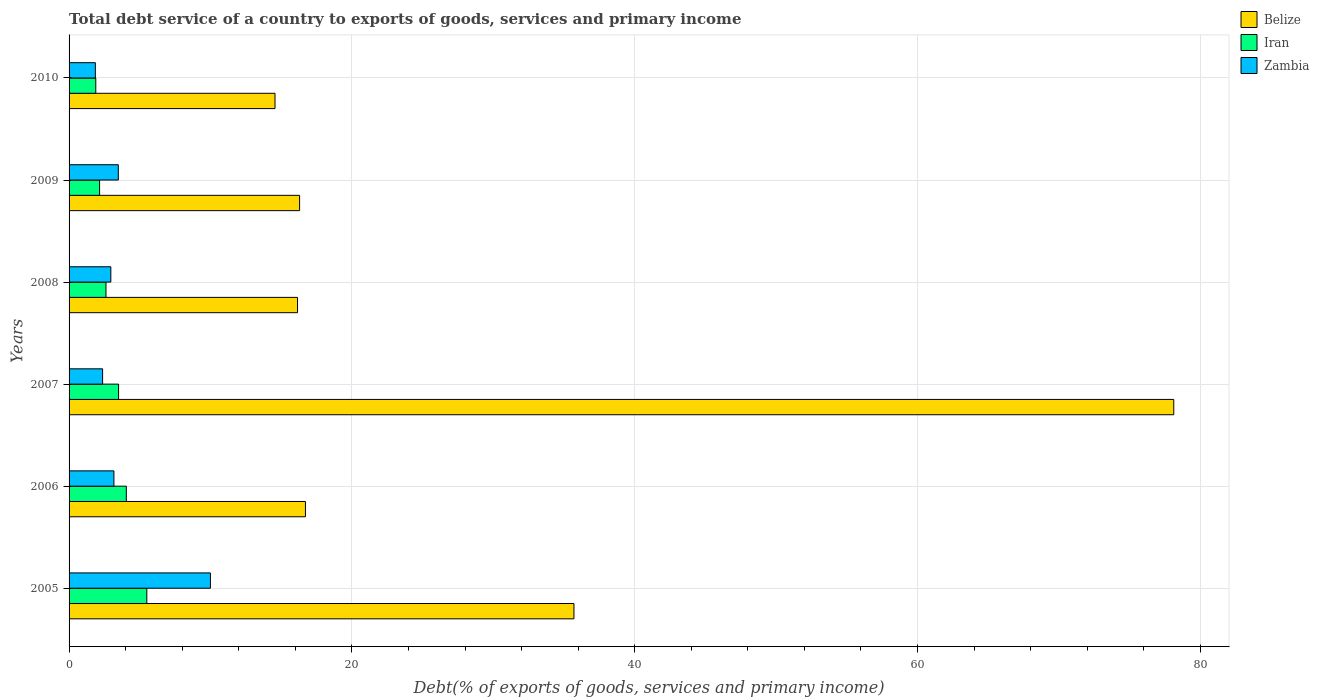How many different coloured bars are there?
Offer a very short reply. 3. How many groups of bars are there?
Make the answer very short. 6. Are the number of bars per tick equal to the number of legend labels?
Your response must be concise. Yes. How many bars are there on the 2nd tick from the top?
Give a very brief answer. 3. What is the label of the 2nd group of bars from the top?
Offer a very short reply. 2009. In how many cases, is the number of bars for a given year not equal to the number of legend labels?
Provide a short and direct response. 0. What is the total debt service in Iran in 2005?
Offer a terse response. 5.5. Across all years, what is the maximum total debt service in Belize?
Keep it short and to the point. 78.12. Across all years, what is the minimum total debt service in Belize?
Your response must be concise. 14.56. In which year was the total debt service in Iran maximum?
Offer a very short reply. 2005. In which year was the total debt service in Belize minimum?
Provide a short and direct response. 2010. What is the total total debt service in Zambia in the graph?
Your response must be concise. 23.83. What is the difference between the total debt service in Belize in 2009 and that in 2010?
Ensure brevity in your answer.  1.74. What is the difference between the total debt service in Zambia in 2006 and the total debt service in Iran in 2008?
Your response must be concise. 0.56. What is the average total debt service in Iran per year?
Offer a terse response. 3.28. In the year 2010, what is the difference between the total debt service in Zambia and total debt service in Belize?
Your answer should be very brief. -12.71. In how many years, is the total debt service in Zambia greater than 24 %?
Your answer should be compact. 0. What is the ratio of the total debt service in Iran in 2005 to that in 2008?
Give a very brief answer. 2.11. Is the difference between the total debt service in Zambia in 2005 and 2006 greater than the difference between the total debt service in Belize in 2005 and 2006?
Ensure brevity in your answer.  No. What is the difference between the highest and the second highest total debt service in Belize?
Provide a short and direct response. 42.42. What is the difference between the highest and the lowest total debt service in Zambia?
Your answer should be compact. 8.14. In how many years, is the total debt service in Iran greater than the average total debt service in Iran taken over all years?
Provide a short and direct response. 3. Is the sum of the total debt service in Belize in 2007 and 2008 greater than the maximum total debt service in Iran across all years?
Provide a succinct answer. Yes. What does the 3rd bar from the top in 2009 represents?
Your response must be concise. Belize. What does the 2nd bar from the bottom in 2006 represents?
Offer a terse response. Iran. How many years are there in the graph?
Provide a short and direct response. 6. What is the difference between two consecutive major ticks on the X-axis?
Make the answer very short. 20. Where does the legend appear in the graph?
Ensure brevity in your answer.  Top right. How many legend labels are there?
Your answer should be compact. 3. How are the legend labels stacked?
Offer a terse response. Vertical. What is the title of the graph?
Make the answer very short. Total debt service of a country to exports of goods, services and primary income. What is the label or title of the X-axis?
Provide a short and direct response. Debt(% of exports of goods, services and primary income). What is the Debt(% of exports of goods, services and primary income) of Belize in 2005?
Your response must be concise. 35.7. What is the Debt(% of exports of goods, services and primary income) of Iran in 2005?
Keep it short and to the point. 5.5. What is the Debt(% of exports of goods, services and primary income) in Zambia in 2005?
Make the answer very short. 10. What is the Debt(% of exports of goods, services and primary income) of Belize in 2006?
Offer a very short reply. 16.72. What is the Debt(% of exports of goods, services and primary income) of Iran in 2006?
Keep it short and to the point. 4.05. What is the Debt(% of exports of goods, services and primary income) in Zambia in 2006?
Provide a short and direct response. 3.17. What is the Debt(% of exports of goods, services and primary income) in Belize in 2007?
Your answer should be very brief. 78.12. What is the Debt(% of exports of goods, services and primary income) of Iran in 2007?
Keep it short and to the point. 3.5. What is the Debt(% of exports of goods, services and primary income) of Zambia in 2007?
Provide a succinct answer. 2.37. What is the Debt(% of exports of goods, services and primary income) in Belize in 2008?
Offer a very short reply. 16.16. What is the Debt(% of exports of goods, services and primary income) of Iran in 2008?
Offer a terse response. 2.61. What is the Debt(% of exports of goods, services and primary income) of Zambia in 2008?
Your response must be concise. 2.95. What is the Debt(% of exports of goods, services and primary income) in Belize in 2009?
Ensure brevity in your answer.  16.3. What is the Debt(% of exports of goods, services and primary income) of Iran in 2009?
Your answer should be very brief. 2.16. What is the Debt(% of exports of goods, services and primary income) in Zambia in 2009?
Offer a terse response. 3.48. What is the Debt(% of exports of goods, services and primary income) of Belize in 2010?
Provide a succinct answer. 14.56. What is the Debt(% of exports of goods, services and primary income) of Iran in 2010?
Make the answer very short. 1.89. What is the Debt(% of exports of goods, services and primary income) in Zambia in 2010?
Make the answer very short. 1.86. Across all years, what is the maximum Debt(% of exports of goods, services and primary income) of Belize?
Your response must be concise. 78.12. Across all years, what is the maximum Debt(% of exports of goods, services and primary income) in Iran?
Ensure brevity in your answer.  5.5. Across all years, what is the maximum Debt(% of exports of goods, services and primary income) in Zambia?
Make the answer very short. 10. Across all years, what is the minimum Debt(% of exports of goods, services and primary income) of Belize?
Make the answer very short. 14.56. Across all years, what is the minimum Debt(% of exports of goods, services and primary income) of Iran?
Your answer should be very brief. 1.89. Across all years, what is the minimum Debt(% of exports of goods, services and primary income) of Zambia?
Provide a succinct answer. 1.86. What is the total Debt(% of exports of goods, services and primary income) of Belize in the graph?
Your answer should be compact. 177.57. What is the total Debt(% of exports of goods, services and primary income) in Iran in the graph?
Offer a very short reply. 19.71. What is the total Debt(% of exports of goods, services and primary income) in Zambia in the graph?
Make the answer very short. 23.83. What is the difference between the Debt(% of exports of goods, services and primary income) in Belize in 2005 and that in 2006?
Keep it short and to the point. 18.99. What is the difference between the Debt(% of exports of goods, services and primary income) of Iran in 2005 and that in 2006?
Your answer should be compact. 1.45. What is the difference between the Debt(% of exports of goods, services and primary income) of Zambia in 2005 and that in 2006?
Provide a succinct answer. 6.83. What is the difference between the Debt(% of exports of goods, services and primary income) in Belize in 2005 and that in 2007?
Give a very brief answer. -42.42. What is the difference between the Debt(% of exports of goods, services and primary income) in Iran in 2005 and that in 2007?
Your response must be concise. 2. What is the difference between the Debt(% of exports of goods, services and primary income) of Zambia in 2005 and that in 2007?
Your answer should be compact. 7.63. What is the difference between the Debt(% of exports of goods, services and primary income) of Belize in 2005 and that in 2008?
Your response must be concise. 19.55. What is the difference between the Debt(% of exports of goods, services and primary income) in Iran in 2005 and that in 2008?
Your answer should be compact. 2.89. What is the difference between the Debt(% of exports of goods, services and primary income) of Zambia in 2005 and that in 2008?
Keep it short and to the point. 7.04. What is the difference between the Debt(% of exports of goods, services and primary income) of Belize in 2005 and that in 2009?
Make the answer very short. 19.4. What is the difference between the Debt(% of exports of goods, services and primary income) of Iran in 2005 and that in 2009?
Offer a very short reply. 3.34. What is the difference between the Debt(% of exports of goods, services and primary income) in Zambia in 2005 and that in 2009?
Your answer should be compact. 6.52. What is the difference between the Debt(% of exports of goods, services and primary income) in Belize in 2005 and that in 2010?
Give a very brief answer. 21.14. What is the difference between the Debt(% of exports of goods, services and primary income) in Iran in 2005 and that in 2010?
Your answer should be compact. 3.61. What is the difference between the Debt(% of exports of goods, services and primary income) of Zambia in 2005 and that in 2010?
Offer a very short reply. 8.14. What is the difference between the Debt(% of exports of goods, services and primary income) of Belize in 2006 and that in 2007?
Your response must be concise. -61.41. What is the difference between the Debt(% of exports of goods, services and primary income) of Iran in 2006 and that in 2007?
Your response must be concise. 0.55. What is the difference between the Debt(% of exports of goods, services and primary income) of Zambia in 2006 and that in 2007?
Give a very brief answer. 0.8. What is the difference between the Debt(% of exports of goods, services and primary income) in Belize in 2006 and that in 2008?
Offer a very short reply. 0.56. What is the difference between the Debt(% of exports of goods, services and primary income) in Iran in 2006 and that in 2008?
Keep it short and to the point. 1.44. What is the difference between the Debt(% of exports of goods, services and primary income) of Zambia in 2006 and that in 2008?
Your answer should be very brief. 0.22. What is the difference between the Debt(% of exports of goods, services and primary income) of Belize in 2006 and that in 2009?
Your answer should be very brief. 0.41. What is the difference between the Debt(% of exports of goods, services and primary income) in Iran in 2006 and that in 2009?
Give a very brief answer. 1.89. What is the difference between the Debt(% of exports of goods, services and primary income) in Zambia in 2006 and that in 2009?
Keep it short and to the point. -0.31. What is the difference between the Debt(% of exports of goods, services and primary income) in Belize in 2006 and that in 2010?
Offer a very short reply. 2.15. What is the difference between the Debt(% of exports of goods, services and primary income) of Iran in 2006 and that in 2010?
Offer a very short reply. 2.16. What is the difference between the Debt(% of exports of goods, services and primary income) of Zambia in 2006 and that in 2010?
Provide a succinct answer. 1.31. What is the difference between the Debt(% of exports of goods, services and primary income) in Belize in 2007 and that in 2008?
Offer a very short reply. 61.97. What is the difference between the Debt(% of exports of goods, services and primary income) in Iran in 2007 and that in 2008?
Give a very brief answer. 0.89. What is the difference between the Debt(% of exports of goods, services and primary income) in Zambia in 2007 and that in 2008?
Provide a succinct answer. -0.58. What is the difference between the Debt(% of exports of goods, services and primary income) in Belize in 2007 and that in 2009?
Provide a succinct answer. 61.82. What is the difference between the Debt(% of exports of goods, services and primary income) of Iran in 2007 and that in 2009?
Your answer should be very brief. 1.34. What is the difference between the Debt(% of exports of goods, services and primary income) of Zambia in 2007 and that in 2009?
Offer a terse response. -1.11. What is the difference between the Debt(% of exports of goods, services and primary income) in Belize in 2007 and that in 2010?
Ensure brevity in your answer.  63.56. What is the difference between the Debt(% of exports of goods, services and primary income) of Iran in 2007 and that in 2010?
Ensure brevity in your answer.  1.61. What is the difference between the Debt(% of exports of goods, services and primary income) in Zambia in 2007 and that in 2010?
Provide a short and direct response. 0.51. What is the difference between the Debt(% of exports of goods, services and primary income) in Belize in 2008 and that in 2009?
Offer a very short reply. -0.15. What is the difference between the Debt(% of exports of goods, services and primary income) of Iran in 2008 and that in 2009?
Make the answer very short. 0.45. What is the difference between the Debt(% of exports of goods, services and primary income) in Zambia in 2008 and that in 2009?
Your answer should be very brief. -0.53. What is the difference between the Debt(% of exports of goods, services and primary income) in Belize in 2008 and that in 2010?
Give a very brief answer. 1.59. What is the difference between the Debt(% of exports of goods, services and primary income) in Iran in 2008 and that in 2010?
Offer a very short reply. 0.72. What is the difference between the Debt(% of exports of goods, services and primary income) of Zambia in 2008 and that in 2010?
Make the answer very short. 1.09. What is the difference between the Debt(% of exports of goods, services and primary income) of Belize in 2009 and that in 2010?
Offer a terse response. 1.74. What is the difference between the Debt(% of exports of goods, services and primary income) in Iran in 2009 and that in 2010?
Your response must be concise. 0.27. What is the difference between the Debt(% of exports of goods, services and primary income) in Zambia in 2009 and that in 2010?
Ensure brevity in your answer.  1.62. What is the difference between the Debt(% of exports of goods, services and primary income) of Belize in 2005 and the Debt(% of exports of goods, services and primary income) of Iran in 2006?
Your answer should be compact. 31.66. What is the difference between the Debt(% of exports of goods, services and primary income) of Belize in 2005 and the Debt(% of exports of goods, services and primary income) of Zambia in 2006?
Make the answer very short. 32.53. What is the difference between the Debt(% of exports of goods, services and primary income) in Iran in 2005 and the Debt(% of exports of goods, services and primary income) in Zambia in 2006?
Keep it short and to the point. 2.33. What is the difference between the Debt(% of exports of goods, services and primary income) of Belize in 2005 and the Debt(% of exports of goods, services and primary income) of Iran in 2007?
Offer a terse response. 32.2. What is the difference between the Debt(% of exports of goods, services and primary income) in Belize in 2005 and the Debt(% of exports of goods, services and primary income) in Zambia in 2007?
Make the answer very short. 33.33. What is the difference between the Debt(% of exports of goods, services and primary income) of Iran in 2005 and the Debt(% of exports of goods, services and primary income) of Zambia in 2007?
Give a very brief answer. 3.13. What is the difference between the Debt(% of exports of goods, services and primary income) of Belize in 2005 and the Debt(% of exports of goods, services and primary income) of Iran in 2008?
Offer a terse response. 33.09. What is the difference between the Debt(% of exports of goods, services and primary income) of Belize in 2005 and the Debt(% of exports of goods, services and primary income) of Zambia in 2008?
Your answer should be compact. 32.75. What is the difference between the Debt(% of exports of goods, services and primary income) in Iran in 2005 and the Debt(% of exports of goods, services and primary income) in Zambia in 2008?
Give a very brief answer. 2.54. What is the difference between the Debt(% of exports of goods, services and primary income) of Belize in 2005 and the Debt(% of exports of goods, services and primary income) of Iran in 2009?
Your response must be concise. 33.55. What is the difference between the Debt(% of exports of goods, services and primary income) of Belize in 2005 and the Debt(% of exports of goods, services and primary income) of Zambia in 2009?
Provide a short and direct response. 32.22. What is the difference between the Debt(% of exports of goods, services and primary income) of Iran in 2005 and the Debt(% of exports of goods, services and primary income) of Zambia in 2009?
Make the answer very short. 2.02. What is the difference between the Debt(% of exports of goods, services and primary income) of Belize in 2005 and the Debt(% of exports of goods, services and primary income) of Iran in 2010?
Offer a terse response. 33.82. What is the difference between the Debt(% of exports of goods, services and primary income) of Belize in 2005 and the Debt(% of exports of goods, services and primary income) of Zambia in 2010?
Give a very brief answer. 33.85. What is the difference between the Debt(% of exports of goods, services and primary income) of Iran in 2005 and the Debt(% of exports of goods, services and primary income) of Zambia in 2010?
Give a very brief answer. 3.64. What is the difference between the Debt(% of exports of goods, services and primary income) of Belize in 2006 and the Debt(% of exports of goods, services and primary income) of Iran in 2007?
Make the answer very short. 13.22. What is the difference between the Debt(% of exports of goods, services and primary income) in Belize in 2006 and the Debt(% of exports of goods, services and primary income) in Zambia in 2007?
Your answer should be compact. 14.35. What is the difference between the Debt(% of exports of goods, services and primary income) in Iran in 2006 and the Debt(% of exports of goods, services and primary income) in Zambia in 2007?
Offer a very short reply. 1.68. What is the difference between the Debt(% of exports of goods, services and primary income) of Belize in 2006 and the Debt(% of exports of goods, services and primary income) of Iran in 2008?
Keep it short and to the point. 14.11. What is the difference between the Debt(% of exports of goods, services and primary income) in Belize in 2006 and the Debt(% of exports of goods, services and primary income) in Zambia in 2008?
Keep it short and to the point. 13.76. What is the difference between the Debt(% of exports of goods, services and primary income) in Iran in 2006 and the Debt(% of exports of goods, services and primary income) in Zambia in 2008?
Your response must be concise. 1.09. What is the difference between the Debt(% of exports of goods, services and primary income) in Belize in 2006 and the Debt(% of exports of goods, services and primary income) in Iran in 2009?
Provide a short and direct response. 14.56. What is the difference between the Debt(% of exports of goods, services and primary income) in Belize in 2006 and the Debt(% of exports of goods, services and primary income) in Zambia in 2009?
Ensure brevity in your answer.  13.24. What is the difference between the Debt(% of exports of goods, services and primary income) of Iran in 2006 and the Debt(% of exports of goods, services and primary income) of Zambia in 2009?
Make the answer very short. 0.57. What is the difference between the Debt(% of exports of goods, services and primary income) of Belize in 2006 and the Debt(% of exports of goods, services and primary income) of Iran in 2010?
Your response must be concise. 14.83. What is the difference between the Debt(% of exports of goods, services and primary income) in Belize in 2006 and the Debt(% of exports of goods, services and primary income) in Zambia in 2010?
Your response must be concise. 14.86. What is the difference between the Debt(% of exports of goods, services and primary income) in Iran in 2006 and the Debt(% of exports of goods, services and primary income) in Zambia in 2010?
Your response must be concise. 2.19. What is the difference between the Debt(% of exports of goods, services and primary income) of Belize in 2007 and the Debt(% of exports of goods, services and primary income) of Iran in 2008?
Make the answer very short. 75.51. What is the difference between the Debt(% of exports of goods, services and primary income) in Belize in 2007 and the Debt(% of exports of goods, services and primary income) in Zambia in 2008?
Offer a very short reply. 75.17. What is the difference between the Debt(% of exports of goods, services and primary income) of Iran in 2007 and the Debt(% of exports of goods, services and primary income) of Zambia in 2008?
Provide a short and direct response. 0.55. What is the difference between the Debt(% of exports of goods, services and primary income) in Belize in 2007 and the Debt(% of exports of goods, services and primary income) in Iran in 2009?
Give a very brief answer. 75.96. What is the difference between the Debt(% of exports of goods, services and primary income) of Belize in 2007 and the Debt(% of exports of goods, services and primary income) of Zambia in 2009?
Make the answer very short. 74.64. What is the difference between the Debt(% of exports of goods, services and primary income) of Iran in 2007 and the Debt(% of exports of goods, services and primary income) of Zambia in 2009?
Offer a very short reply. 0.02. What is the difference between the Debt(% of exports of goods, services and primary income) of Belize in 2007 and the Debt(% of exports of goods, services and primary income) of Iran in 2010?
Your answer should be very brief. 76.23. What is the difference between the Debt(% of exports of goods, services and primary income) in Belize in 2007 and the Debt(% of exports of goods, services and primary income) in Zambia in 2010?
Your answer should be compact. 76.27. What is the difference between the Debt(% of exports of goods, services and primary income) in Iran in 2007 and the Debt(% of exports of goods, services and primary income) in Zambia in 2010?
Provide a succinct answer. 1.64. What is the difference between the Debt(% of exports of goods, services and primary income) in Belize in 2008 and the Debt(% of exports of goods, services and primary income) in Iran in 2009?
Keep it short and to the point. 14. What is the difference between the Debt(% of exports of goods, services and primary income) in Belize in 2008 and the Debt(% of exports of goods, services and primary income) in Zambia in 2009?
Provide a succinct answer. 12.67. What is the difference between the Debt(% of exports of goods, services and primary income) of Iran in 2008 and the Debt(% of exports of goods, services and primary income) of Zambia in 2009?
Your answer should be compact. -0.87. What is the difference between the Debt(% of exports of goods, services and primary income) of Belize in 2008 and the Debt(% of exports of goods, services and primary income) of Iran in 2010?
Your answer should be very brief. 14.27. What is the difference between the Debt(% of exports of goods, services and primary income) in Belize in 2008 and the Debt(% of exports of goods, services and primary income) in Zambia in 2010?
Provide a succinct answer. 14.3. What is the difference between the Debt(% of exports of goods, services and primary income) in Iran in 2008 and the Debt(% of exports of goods, services and primary income) in Zambia in 2010?
Offer a very short reply. 0.75. What is the difference between the Debt(% of exports of goods, services and primary income) in Belize in 2009 and the Debt(% of exports of goods, services and primary income) in Iran in 2010?
Offer a terse response. 14.41. What is the difference between the Debt(% of exports of goods, services and primary income) in Belize in 2009 and the Debt(% of exports of goods, services and primary income) in Zambia in 2010?
Provide a succinct answer. 14.44. What is the difference between the Debt(% of exports of goods, services and primary income) in Iran in 2009 and the Debt(% of exports of goods, services and primary income) in Zambia in 2010?
Offer a terse response. 0.3. What is the average Debt(% of exports of goods, services and primary income) of Belize per year?
Keep it short and to the point. 29.59. What is the average Debt(% of exports of goods, services and primary income) in Iran per year?
Offer a very short reply. 3.28. What is the average Debt(% of exports of goods, services and primary income) in Zambia per year?
Make the answer very short. 3.97. In the year 2005, what is the difference between the Debt(% of exports of goods, services and primary income) of Belize and Debt(% of exports of goods, services and primary income) of Iran?
Your response must be concise. 30.21. In the year 2005, what is the difference between the Debt(% of exports of goods, services and primary income) of Belize and Debt(% of exports of goods, services and primary income) of Zambia?
Offer a terse response. 25.71. In the year 2005, what is the difference between the Debt(% of exports of goods, services and primary income) in Iran and Debt(% of exports of goods, services and primary income) in Zambia?
Offer a terse response. -4.5. In the year 2006, what is the difference between the Debt(% of exports of goods, services and primary income) in Belize and Debt(% of exports of goods, services and primary income) in Iran?
Give a very brief answer. 12.67. In the year 2006, what is the difference between the Debt(% of exports of goods, services and primary income) of Belize and Debt(% of exports of goods, services and primary income) of Zambia?
Keep it short and to the point. 13.55. In the year 2006, what is the difference between the Debt(% of exports of goods, services and primary income) of Iran and Debt(% of exports of goods, services and primary income) of Zambia?
Give a very brief answer. 0.88. In the year 2007, what is the difference between the Debt(% of exports of goods, services and primary income) of Belize and Debt(% of exports of goods, services and primary income) of Iran?
Offer a terse response. 74.62. In the year 2007, what is the difference between the Debt(% of exports of goods, services and primary income) in Belize and Debt(% of exports of goods, services and primary income) in Zambia?
Your answer should be compact. 75.75. In the year 2007, what is the difference between the Debt(% of exports of goods, services and primary income) of Iran and Debt(% of exports of goods, services and primary income) of Zambia?
Make the answer very short. 1.13. In the year 2008, what is the difference between the Debt(% of exports of goods, services and primary income) of Belize and Debt(% of exports of goods, services and primary income) of Iran?
Keep it short and to the point. 13.55. In the year 2008, what is the difference between the Debt(% of exports of goods, services and primary income) of Belize and Debt(% of exports of goods, services and primary income) of Zambia?
Your response must be concise. 13.2. In the year 2008, what is the difference between the Debt(% of exports of goods, services and primary income) in Iran and Debt(% of exports of goods, services and primary income) in Zambia?
Provide a short and direct response. -0.34. In the year 2009, what is the difference between the Debt(% of exports of goods, services and primary income) of Belize and Debt(% of exports of goods, services and primary income) of Iran?
Your answer should be compact. 14.14. In the year 2009, what is the difference between the Debt(% of exports of goods, services and primary income) in Belize and Debt(% of exports of goods, services and primary income) in Zambia?
Keep it short and to the point. 12.82. In the year 2009, what is the difference between the Debt(% of exports of goods, services and primary income) in Iran and Debt(% of exports of goods, services and primary income) in Zambia?
Your response must be concise. -1.32. In the year 2010, what is the difference between the Debt(% of exports of goods, services and primary income) in Belize and Debt(% of exports of goods, services and primary income) in Iran?
Your answer should be very brief. 12.68. In the year 2010, what is the difference between the Debt(% of exports of goods, services and primary income) of Belize and Debt(% of exports of goods, services and primary income) of Zambia?
Ensure brevity in your answer.  12.71. In the year 2010, what is the difference between the Debt(% of exports of goods, services and primary income) in Iran and Debt(% of exports of goods, services and primary income) in Zambia?
Provide a succinct answer. 0.03. What is the ratio of the Debt(% of exports of goods, services and primary income) in Belize in 2005 to that in 2006?
Provide a succinct answer. 2.14. What is the ratio of the Debt(% of exports of goods, services and primary income) in Iran in 2005 to that in 2006?
Provide a succinct answer. 1.36. What is the ratio of the Debt(% of exports of goods, services and primary income) in Zambia in 2005 to that in 2006?
Offer a terse response. 3.15. What is the ratio of the Debt(% of exports of goods, services and primary income) of Belize in 2005 to that in 2007?
Provide a succinct answer. 0.46. What is the ratio of the Debt(% of exports of goods, services and primary income) in Iran in 2005 to that in 2007?
Ensure brevity in your answer.  1.57. What is the ratio of the Debt(% of exports of goods, services and primary income) of Zambia in 2005 to that in 2007?
Make the answer very short. 4.22. What is the ratio of the Debt(% of exports of goods, services and primary income) in Belize in 2005 to that in 2008?
Keep it short and to the point. 2.21. What is the ratio of the Debt(% of exports of goods, services and primary income) in Iran in 2005 to that in 2008?
Your answer should be compact. 2.11. What is the ratio of the Debt(% of exports of goods, services and primary income) in Zambia in 2005 to that in 2008?
Your response must be concise. 3.39. What is the ratio of the Debt(% of exports of goods, services and primary income) of Belize in 2005 to that in 2009?
Give a very brief answer. 2.19. What is the ratio of the Debt(% of exports of goods, services and primary income) of Iran in 2005 to that in 2009?
Offer a terse response. 2.55. What is the ratio of the Debt(% of exports of goods, services and primary income) in Zambia in 2005 to that in 2009?
Keep it short and to the point. 2.87. What is the ratio of the Debt(% of exports of goods, services and primary income) in Belize in 2005 to that in 2010?
Provide a succinct answer. 2.45. What is the ratio of the Debt(% of exports of goods, services and primary income) in Iran in 2005 to that in 2010?
Your response must be concise. 2.91. What is the ratio of the Debt(% of exports of goods, services and primary income) in Zambia in 2005 to that in 2010?
Offer a very short reply. 5.38. What is the ratio of the Debt(% of exports of goods, services and primary income) of Belize in 2006 to that in 2007?
Your response must be concise. 0.21. What is the ratio of the Debt(% of exports of goods, services and primary income) in Iran in 2006 to that in 2007?
Keep it short and to the point. 1.16. What is the ratio of the Debt(% of exports of goods, services and primary income) in Zambia in 2006 to that in 2007?
Ensure brevity in your answer.  1.34. What is the ratio of the Debt(% of exports of goods, services and primary income) in Belize in 2006 to that in 2008?
Provide a succinct answer. 1.03. What is the ratio of the Debt(% of exports of goods, services and primary income) of Iran in 2006 to that in 2008?
Offer a terse response. 1.55. What is the ratio of the Debt(% of exports of goods, services and primary income) of Zambia in 2006 to that in 2008?
Offer a very short reply. 1.07. What is the ratio of the Debt(% of exports of goods, services and primary income) in Belize in 2006 to that in 2009?
Your response must be concise. 1.03. What is the ratio of the Debt(% of exports of goods, services and primary income) in Iran in 2006 to that in 2009?
Offer a very short reply. 1.88. What is the ratio of the Debt(% of exports of goods, services and primary income) in Zambia in 2006 to that in 2009?
Offer a very short reply. 0.91. What is the ratio of the Debt(% of exports of goods, services and primary income) of Belize in 2006 to that in 2010?
Your answer should be very brief. 1.15. What is the ratio of the Debt(% of exports of goods, services and primary income) of Iran in 2006 to that in 2010?
Offer a terse response. 2.14. What is the ratio of the Debt(% of exports of goods, services and primary income) of Zambia in 2006 to that in 2010?
Provide a succinct answer. 1.71. What is the ratio of the Debt(% of exports of goods, services and primary income) of Belize in 2007 to that in 2008?
Provide a short and direct response. 4.84. What is the ratio of the Debt(% of exports of goods, services and primary income) of Iran in 2007 to that in 2008?
Your answer should be very brief. 1.34. What is the ratio of the Debt(% of exports of goods, services and primary income) in Zambia in 2007 to that in 2008?
Your response must be concise. 0.8. What is the ratio of the Debt(% of exports of goods, services and primary income) of Belize in 2007 to that in 2009?
Your answer should be compact. 4.79. What is the ratio of the Debt(% of exports of goods, services and primary income) in Iran in 2007 to that in 2009?
Offer a very short reply. 1.62. What is the ratio of the Debt(% of exports of goods, services and primary income) of Zambia in 2007 to that in 2009?
Your answer should be very brief. 0.68. What is the ratio of the Debt(% of exports of goods, services and primary income) of Belize in 2007 to that in 2010?
Your answer should be very brief. 5.36. What is the ratio of the Debt(% of exports of goods, services and primary income) of Iran in 2007 to that in 2010?
Keep it short and to the point. 1.85. What is the ratio of the Debt(% of exports of goods, services and primary income) in Zambia in 2007 to that in 2010?
Offer a very short reply. 1.28. What is the ratio of the Debt(% of exports of goods, services and primary income) of Iran in 2008 to that in 2009?
Your response must be concise. 1.21. What is the ratio of the Debt(% of exports of goods, services and primary income) in Zambia in 2008 to that in 2009?
Keep it short and to the point. 0.85. What is the ratio of the Debt(% of exports of goods, services and primary income) of Belize in 2008 to that in 2010?
Your response must be concise. 1.11. What is the ratio of the Debt(% of exports of goods, services and primary income) in Iran in 2008 to that in 2010?
Your response must be concise. 1.38. What is the ratio of the Debt(% of exports of goods, services and primary income) in Zambia in 2008 to that in 2010?
Make the answer very short. 1.59. What is the ratio of the Debt(% of exports of goods, services and primary income) in Belize in 2009 to that in 2010?
Ensure brevity in your answer.  1.12. What is the ratio of the Debt(% of exports of goods, services and primary income) of Iran in 2009 to that in 2010?
Give a very brief answer. 1.14. What is the ratio of the Debt(% of exports of goods, services and primary income) in Zambia in 2009 to that in 2010?
Your answer should be compact. 1.87. What is the difference between the highest and the second highest Debt(% of exports of goods, services and primary income) of Belize?
Provide a succinct answer. 42.42. What is the difference between the highest and the second highest Debt(% of exports of goods, services and primary income) in Iran?
Your answer should be very brief. 1.45. What is the difference between the highest and the second highest Debt(% of exports of goods, services and primary income) in Zambia?
Keep it short and to the point. 6.52. What is the difference between the highest and the lowest Debt(% of exports of goods, services and primary income) in Belize?
Your answer should be compact. 63.56. What is the difference between the highest and the lowest Debt(% of exports of goods, services and primary income) of Iran?
Provide a short and direct response. 3.61. What is the difference between the highest and the lowest Debt(% of exports of goods, services and primary income) in Zambia?
Provide a succinct answer. 8.14. 